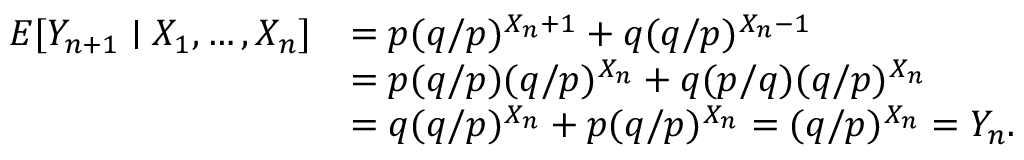Convert formula to latex. <formula><loc_0><loc_0><loc_500><loc_500>{ \begin{array} { r l } { E [ Y _ { n + 1 } | X _ { 1 } , \dots , X _ { n } ] } & { = p ( q / p ) ^ { X _ { n } + 1 } + q ( q / p ) ^ { X _ { n } - 1 } } \\ & { = p ( q / p ) ( q / p ) ^ { X _ { n } } + q ( p / q ) ( q / p ) ^ { X _ { n } } } \\ & { = q ( q / p ) ^ { X _ { n } } + p ( q / p ) ^ { X _ { n } } = ( q / p ) ^ { X _ { n } } = Y _ { n } . } \end{array} }</formula> 